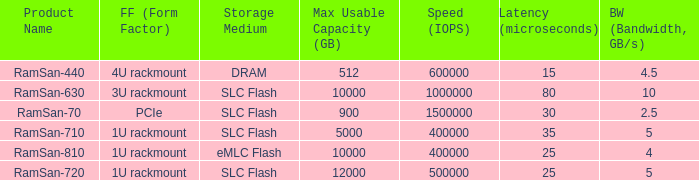List the number of ramsan-720 hard drives? 1.0. Would you be able to parse every entry in this table? {'header': ['Product Name', 'FF (Form Factor)', 'Storage Medium', 'Max Usable Capacity (GB)', 'Speed (IOPS)', 'Latency (microseconds)', 'BW (Bandwidth, GB/s)'], 'rows': [['RamSan-440', '4U rackmount', 'DRAM', '512', '600000', '15', '4.5'], ['RamSan-630', '3U rackmount', 'SLC Flash', '10000', '1000000', '80', '10'], ['RamSan-70', 'PCIe', 'SLC Flash', '900', '1500000', '30', '2.5'], ['RamSan-710', '1U rackmount', 'SLC Flash', '5000', '400000', '35', '5'], ['RamSan-810', '1U rackmount', 'eMLC Flash', '10000', '400000', '25', '4'], ['RamSan-720', '1U rackmount', 'SLC Flash', '12000', '500000', '25', '5']]} 